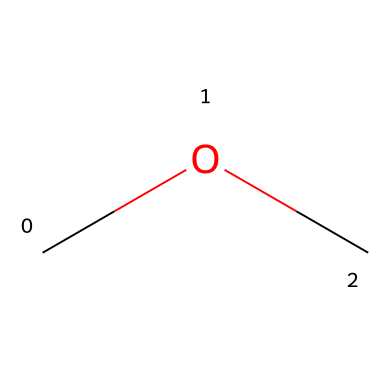What is the molecular formula of dimethyl ether? The SMILES representation "COC" indicates the presence of two carbon (C) atoms, six hydrogen (H) atoms, and one oxygen (O) atom. Therefore, counting these, the molecular formula can be assembled as C2H6O.
Answer: C2H6O How many carbon atoms are in dimethyl ether? From the SMILES notation "COC", we can identify two carbon atoms (represented by 'C') in the structure.
Answer: 2 What type of functional group is present in dimethyl ether? The SMILES "COC" reveals that the ether functional group is characterized by the presence of an oxygen (O) atom connected to two alkyl groups (in this case, two methyl groups). Therefore, the functional group is an ether.
Answer: ether How many hydrogen atoms are present in dimethyl ether? The molecular structure "COC" indicates that there are six hydrogen atoms associated with the two carbon atoms as each methyl group (CH3) contributes three hydrogen atoms, totaling six.
Answer: 6 Is dimethyl ether a polar molecule? The asymmetric arrangement of the oxygen atom, which has a partial negative charge, relative to the carbon atoms creates a dipole moment, indicating that dimethyl ether is polar.
Answer: yes For what purpose is dimethyl ether commonly used? Dimethyl ether is widely utilized as a propellant in aerosol products due to its volatility and effectiveness in carrying the product out of the container.
Answer: propellant 